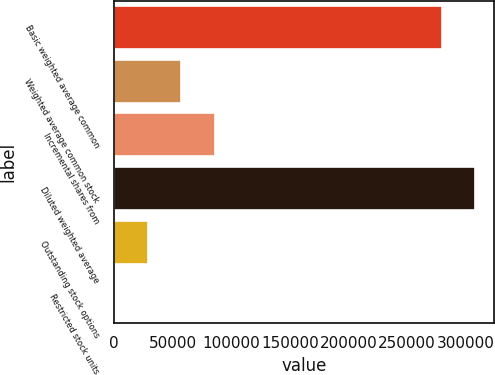<chart> <loc_0><loc_0><loc_500><loc_500><bar_chart><fcel>Basic weighted average common<fcel>Weighted average common stock<fcel>Incremental shares from<fcel>Diluted weighted average<fcel>Outstanding stock options<fcel>Restricted stock units<nl><fcel>279811<fcel>57140.2<fcel>85704.3<fcel>308375<fcel>28576.1<fcel>12<nl></chart> 